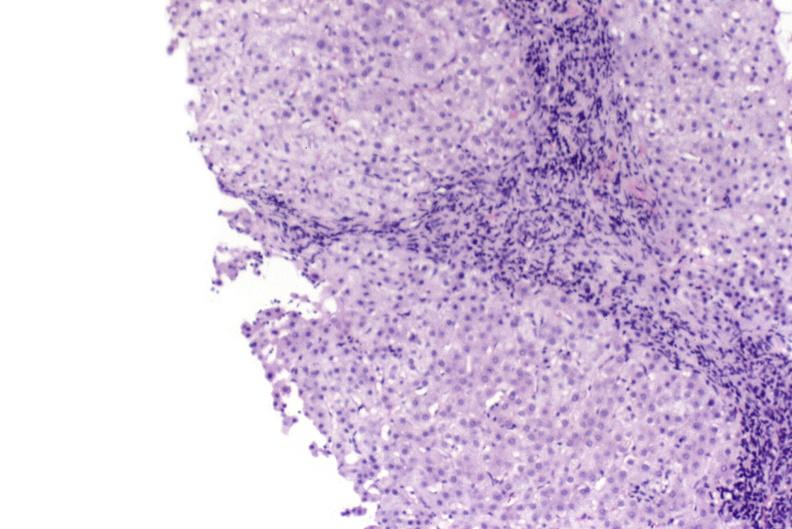what is present?
Answer the question using a single word or phrase. Hepatobiliary 